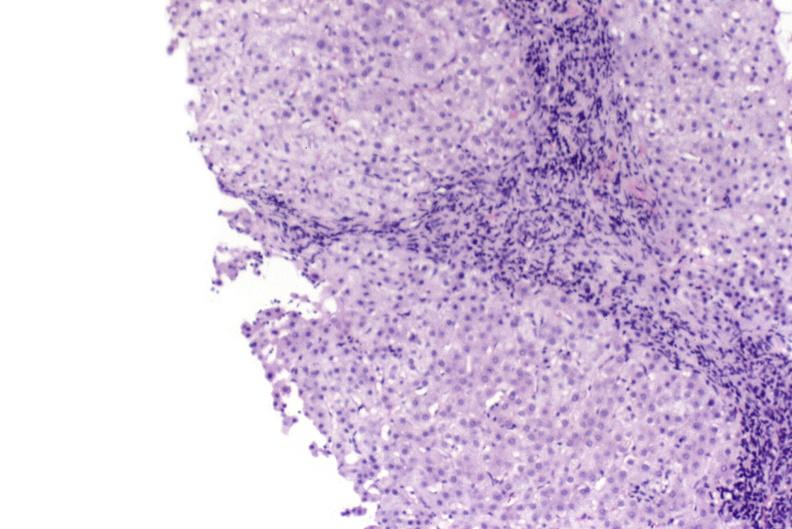what is present?
Answer the question using a single word or phrase. Hepatobiliary 